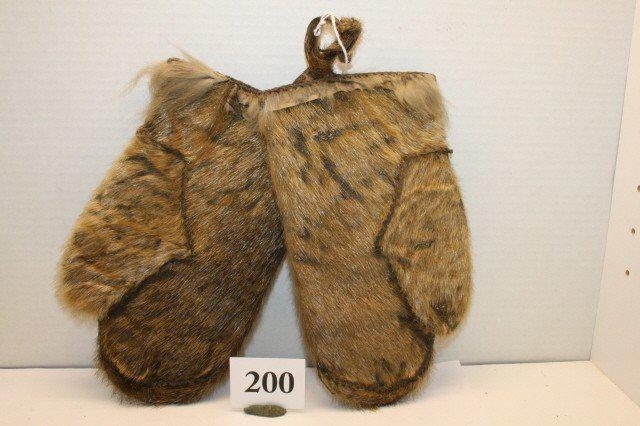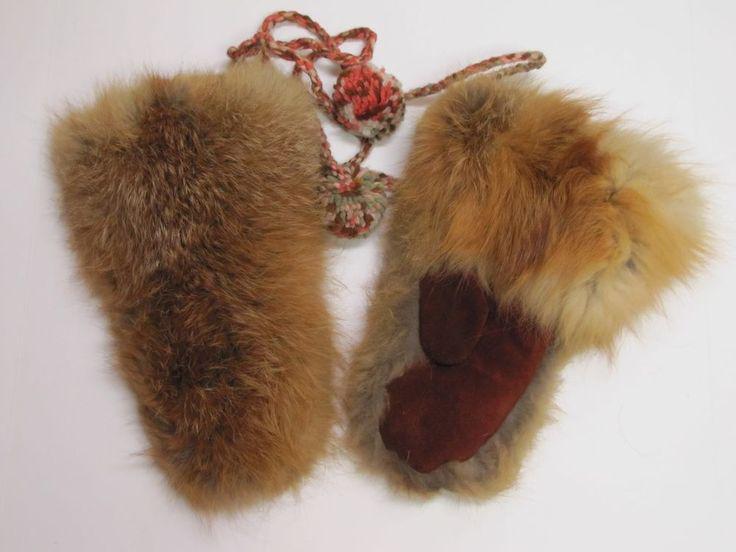The first image is the image on the left, the second image is the image on the right. Evaluate the accuracy of this statement regarding the images: "A tangled cord is part of one image of mitts.". Is it true? Answer yes or no. Yes. 